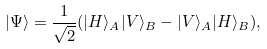<formula> <loc_0><loc_0><loc_500><loc_500>| \Psi \rangle = \frac { 1 } { \sqrt { 2 } } ( | H \rangle _ { A } | V \rangle _ { B } - | V \rangle _ { A } | H \rangle _ { B } ) ,</formula> 